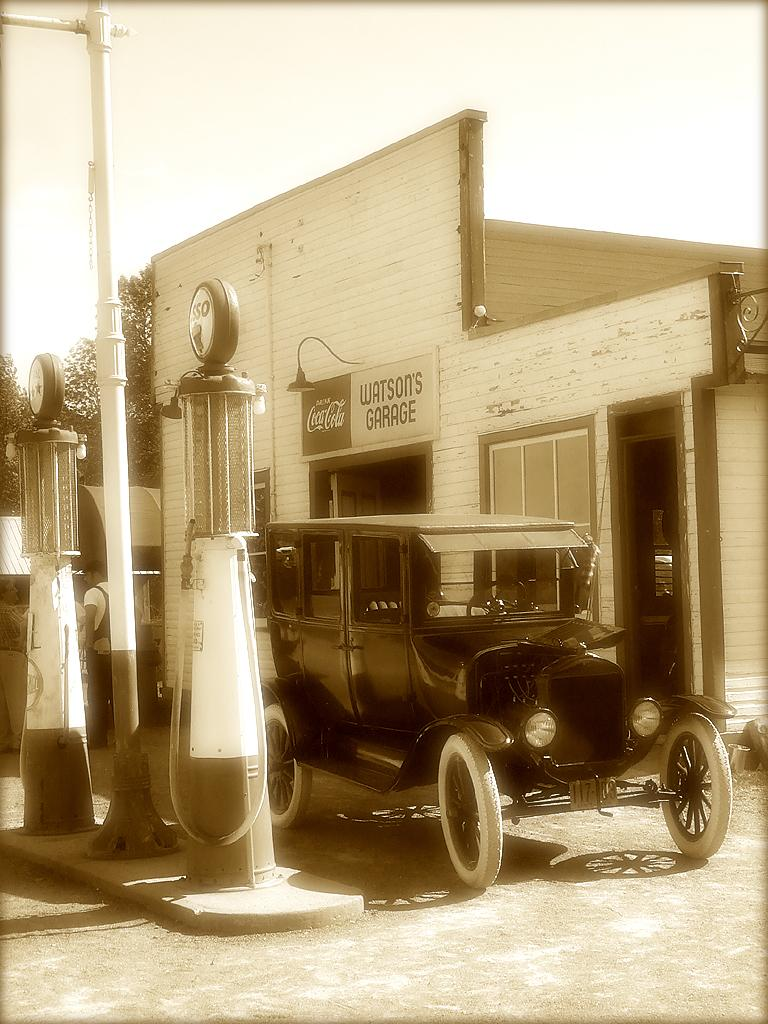What type of establishment is depicted in the image? There is a store in the image. What is displayed on the large sign near the store? There is a hoarding in the image. Can you describe any lighting features in the image? There is a light in the image. What structural elements can be seen in the image? There are poles in the image. What mode of transportation is visible in the image? There is a vehicle in the image. Can you identify any human presence in the image? There is a person in the image. What part of the natural environment is visible in the image? The sky is visible in the image, and there are trees in the image. What is the sister of the person in the image feeling about the store? There is no information about the person's sister or their feelings in the image. How does the acoustics of the store affect the sound quality in the image? There is no information about the acoustics of the store or its impact on sound quality in the image. 